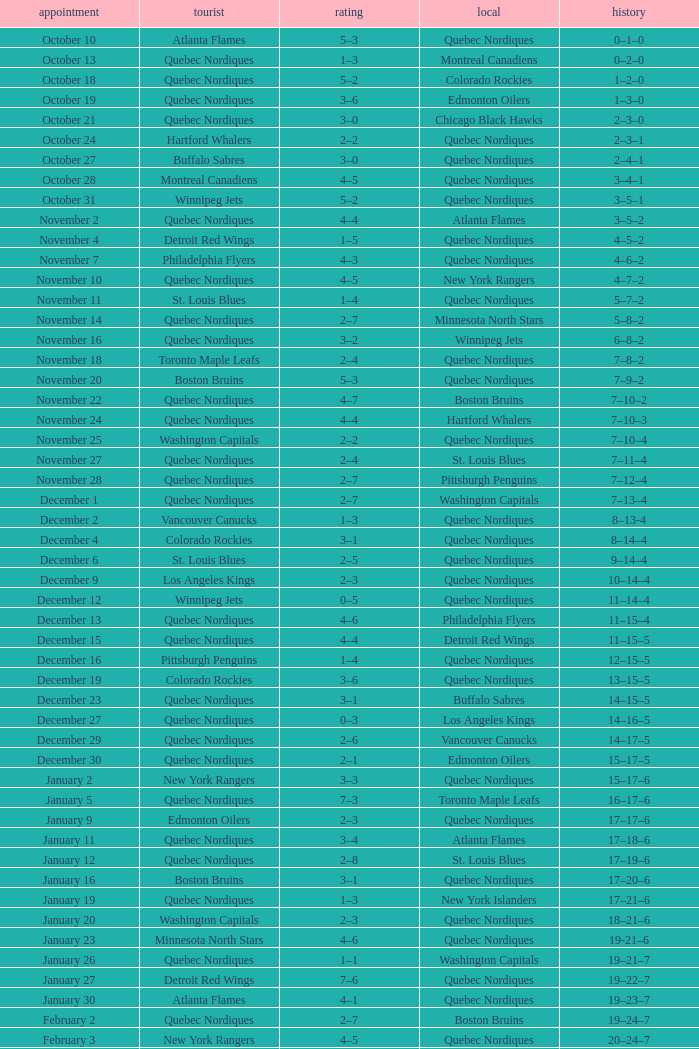Which Home has a Record of 11–14–4? Quebec Nordiques. 